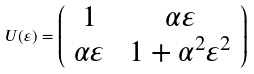<formula> <loc_0><loc_0><loc_500><loc_500>U ( \varepsilon ) = \left ( \begin{array} { c c } 1 & \ \alpha \varepsilon \\ \alpha \varepsilon & \ 1 + \alpha ^ { 2 } \varepsilon ^ { 2 } \end{array} \right )</formula> 